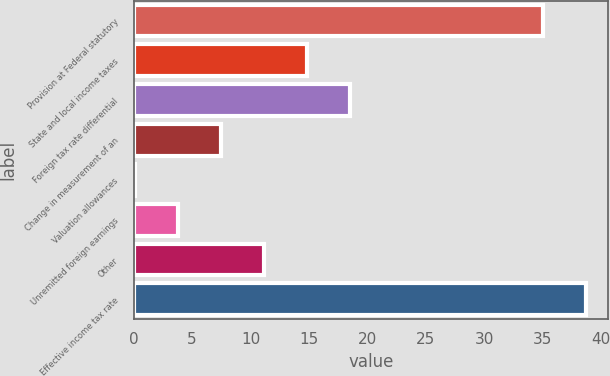<chart> <loc_0><loc_0><loc_500><loc_500><bar_chart><fcel>Provision at Federal statutory<fcel>State and local income taxes<fcel>Foreign tax rate differential<fcel>Change in measurement of an<fcel>Valuation allowances<fcel>Unremitted foreign earnings<fcel>Other<fcel>Effective income tax rate<nl><fcel>35<fcel>14.86<fcel>18.55<fcel>7.48<fcel>0.1<fcel>3.79<fcel>11.17<fcel>38.69<nl></chart> 